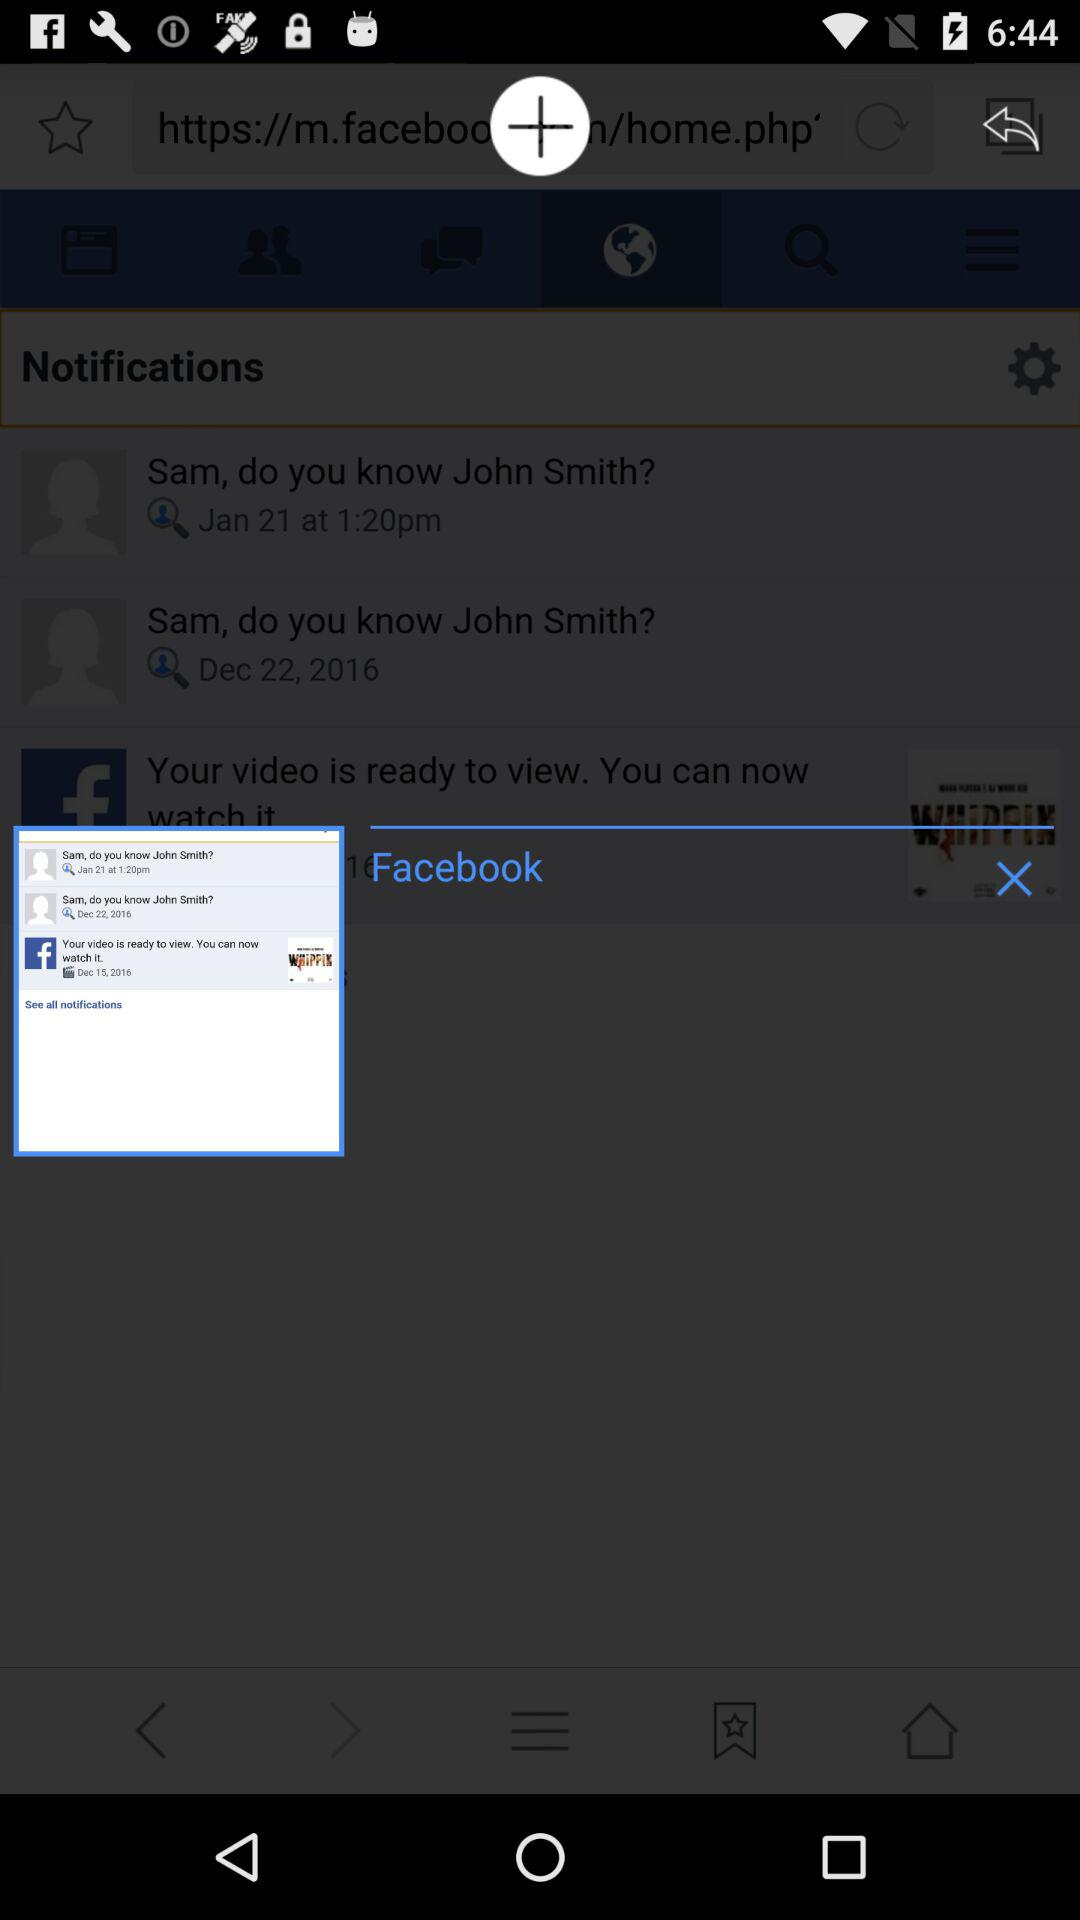How many more notifications are there than people?
Answer the question using a single word or phrase. 1 